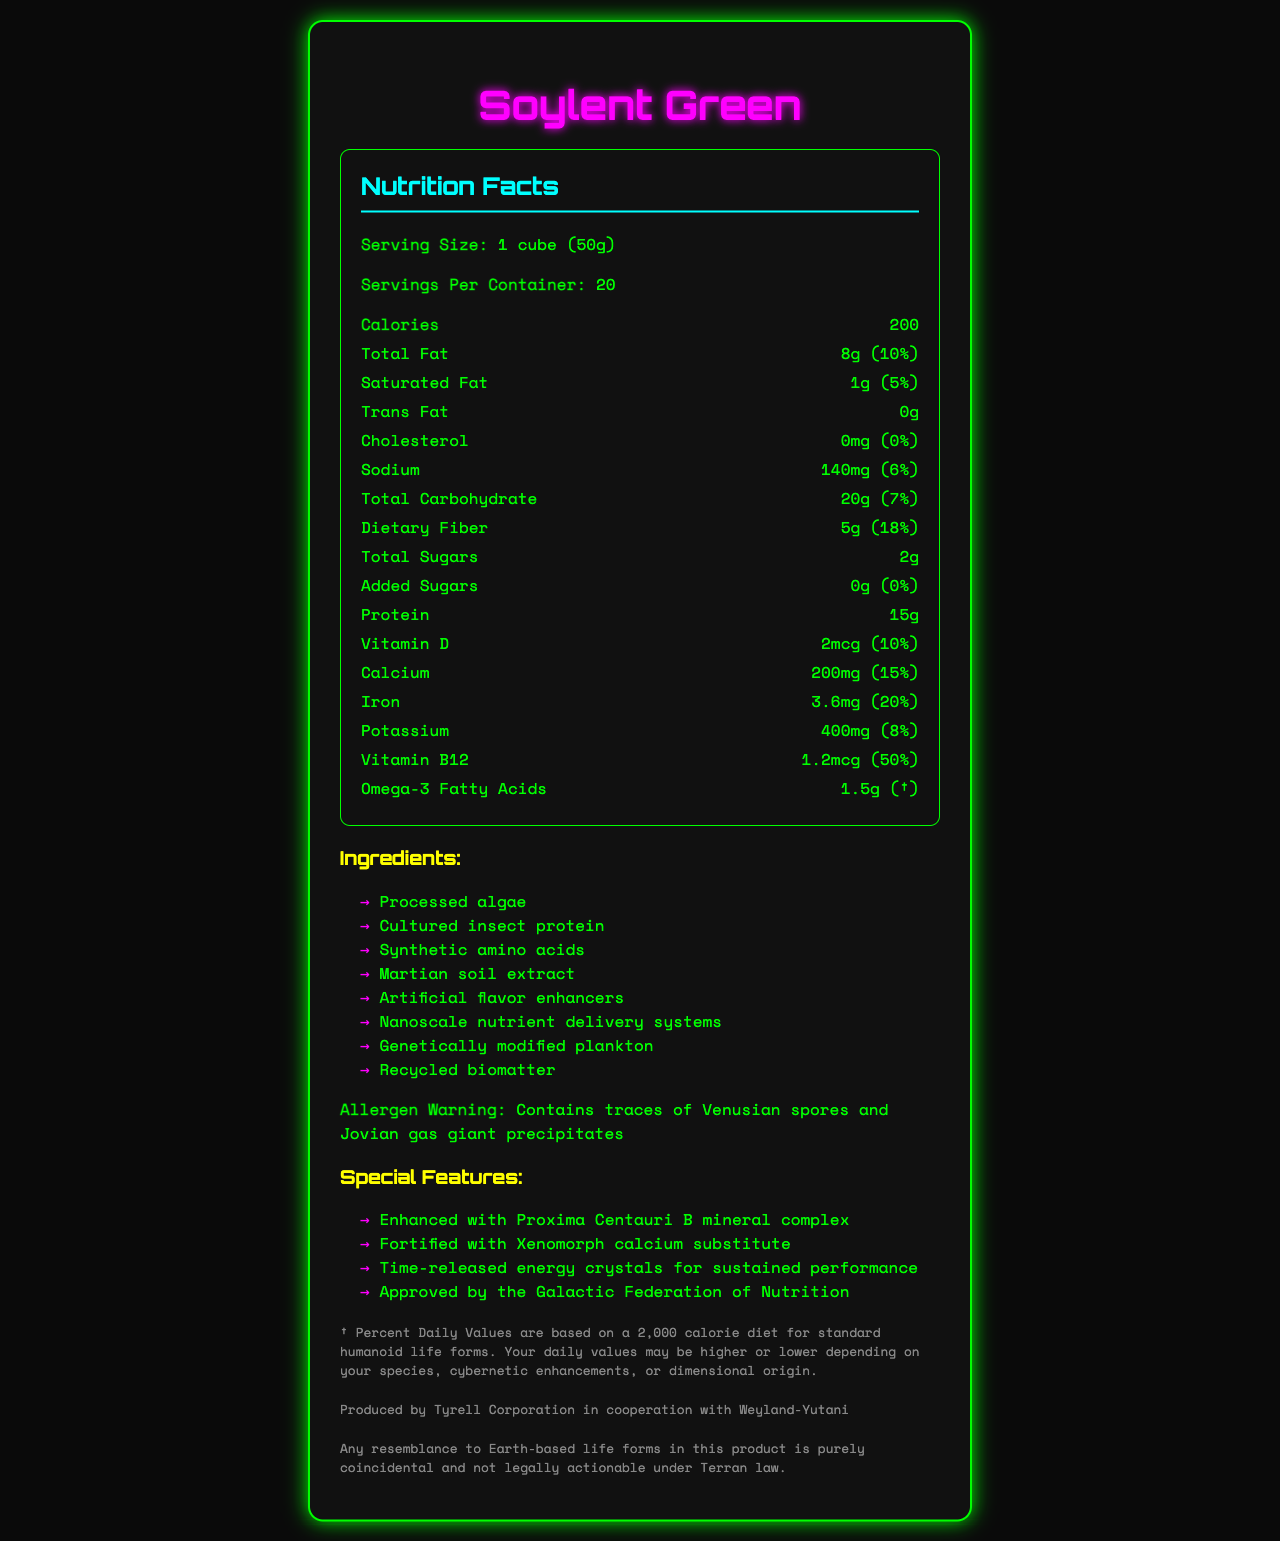what is the serving size of Soylent Green? The serving size is clearly stated in the "Nutrition Facts" section as "1 cube (50g)".
Answer: 1 cube (50g) how many calories are in one serving of Soylent Green? The calories per serving are listed as 200 in the document.
Answer: 200 what are the ingredients of Soylent Green? The ingredients are listed in the section titled "Ingredients".
Answer: Processed algae, Cultured insect protein, Synthetic amino acids, Martian soil extract, Artificial flavor enhancers, Nanoscale nutrient delivery systems, Genetically modified plankton, Recycled biomatter what is the daily value percentage of Vitamin B12 in Soylent Green? The Vitamin B12 content shows 1.2mcg with a 50% daily value percentage.
Answer: 50% which special feature does Soylent Green have? The special features are listed under the "Special Features" section.
Answer: Enhanced with Proxima Centauri B mineral complex, Fortified with Xenomorph calcium substitute, Time-released energy crystals for sustained performance, Approved by the Galactic Federation of Nutrition which of the following is not listed as an ingredient in Soylent Green? A. Processed algae B. Martian soil extract C. Lunar dust D. Genetically modified plankton The ingredient list includes Processed algae, Martian soil extract, and Genetically modified plankton but does not mention Lunar dust.
Answer: C what is the percent daily value of calcium in Soylent Green? A. 10% B. 15% C. 20% D. 25% The nutrition facts list 200mg of calcium with a 15% daily value.
Answer: B is Soylent Green allergen-free? The allergen warning states that it "Contains traces of Venusian spores and Jovian gas giant precipitates".
Answer: No summarize the document The document provides comprehensive dietary information, unique ingredients and features, and necessary warnings and disclaimers about Soylent Green, a futuristic food product.
Answer: The document is a detailed Nutrition Facts label for Soylent Green, a futuristic food substitute. It includes information on serving size, calories, and various nutrients. It lists unique ingredients such as processed algae and synthetic amino acids, along with special features and allergen warnings. It concludes with a disclaimer and manufacturer information. what is the energy source in Soylent Green? The document lists general nutritional information and ingredients but does not specify a primary energy source.
Answer: Not enough information who produces Soylent Green? The manufacturer information section states that it is produced by "Tyrell Corporation in cooperation with Weyland-Yutani".
Answer: Tyrell Corporation in cooperation with Weyland-Yutani 